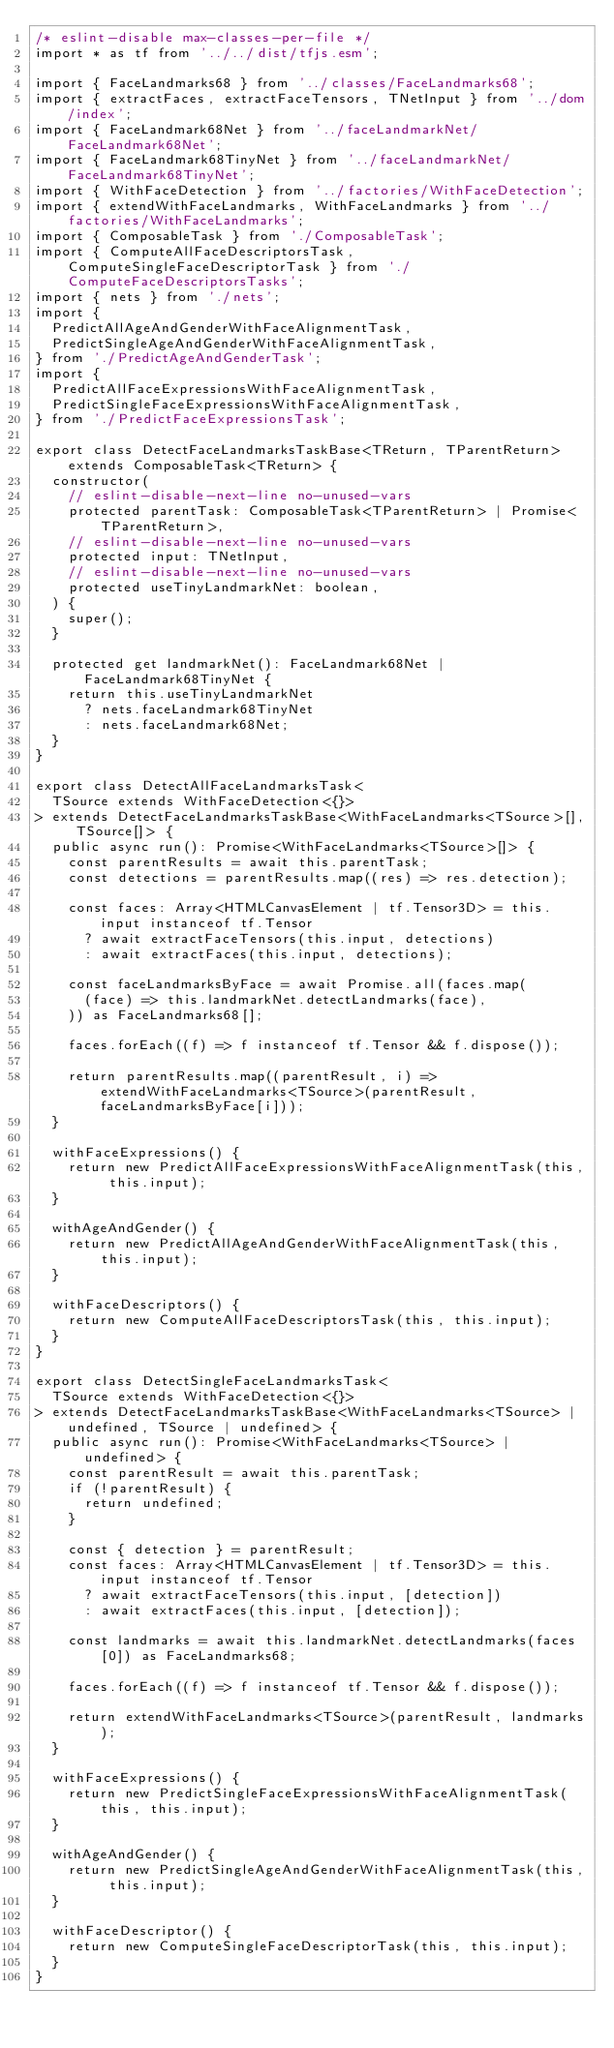<code> <loc_0><loc_0><loc_500><loc_500><_TypeScript_>/* eslint-disable max-classes-per-file */
import * as tf from '../../dist/tfjs.esm';

import { FaceLandmarks68 } from '../classes/FaceLandmarks68';
import { extractFaces, extractFaceTensors, TNetInput } from '../dom/index';
import { FaceLandmark68Net } from '../faceLandmarkNet/FaceLandmark68Net';
import { FaceLandmark68TinyNet } from '../faceLandmarkNet/FaceLandmark68TinyNet';
import { WithFaceDetection } from '../factories/WithFaceDetection';
import { extendWithFaceLandmarks, WithFaceLandmarks } from '../factories/WithFaceLandmarks';
import { ComposableTask } from './ComposableTask';
import { ComputeAllFaceDescriptorsTask, ComputeSingleFaceDescriptorTask } from './ComputeFaceDescriptorsTasks';
import { nets } from './nets';
import {
  PredictAllAgeAndGenderWithFaceAlignmentTask,
  PredictSingleAgeAndGenderWithFaceAlignmentTask,
} from './PredictAgeAndGenderTask';
import {
  PredictAllFaceExpressionsWithFaceAlignmentTask,
  PredictSingleFaceExpressionsWithFaceAlignmentTask,
} from './PredictFaceExpressionsTask';

export class DetectFaceLandmarksTaskBase<TReturn, TParentReturn> extends ComposableTask<TReturn> {
  constructor(
    // eslint-disable-next-line no-unused-vars
    protected parentTask: ComposableTask<TParentReturn> | Promise<TParentReturn>,
    // eslint-disable-next-line no-unused-vars
    protected input: TNetInput,
    // eslint-disable-next-line no-unused-vars
    protected useTinyLandmarkNet: boolean,
  ) {
    super();
  }

  protected get landmarkNet(): FaceLandmark68Net | FaceLandmark68TinyNet {
    return this.useTinyLandmarkNet
      ? nets.faceLandmark68TinyNet
      : nets.faceLandmark68Net;
  }
}

export class DetectAllFaceLandmarksTask<
  TSource extends WithFaceDetection<{}>
> extends DetectFaceLandmarksTaskBase<WithFaceLandmarks<TSource>[], TSource[]> {
  public async run(): Promise<WithFaceLandmarks<TSource>[]> {
    const parentResults = await this.parentTask;
    const detections = parentResults.map((res) => res.detection);

    const faces: Array<HTMLCanvasElement | tf.Tensor3D> = this.input instanceof tf.Tensor
      ? await extractFaceTensors(this.input, detections)
      : await extractFaces(this.input, detections);

    const faceLandmarksByFace = await Promise.all(faces.map(
      (face) => this.landmarkNet.detectLandmarks(face),
    )) as FaceLandmarks68[];

    faces.forEach((f) => f instanceof tf.Tensor && f.dispose());

    return parentResults.map((parentResult, i) => extendWithFaceLandmarks<TSource>(parentResult, faceLandmarksByFace[i]));
  }

  withFaceExpressions() {
    return new PredictAllFaceExpressionsWithFaceAlignmentTask(this, this.input);
  }

  withAgeAndGender() {
    return new PredictAllAgeAndGenderWithFaceAlignmentTask(this, this.input);
  }

  withFaceDescriptors() {
    return new ComputeAllFaceDescriptorsTask(this, this.input);
  }
}

export class DetectSingleFaceLandmarksTask<
  TSource extends WithFaceDetection<{}>
> extends DetectFaceLandmarksTaskBase<WithFaceLandmarks<TSource> | undefined, TSource | undefined> {
  public async run(): Promise<WithFaceLandmarks<TSource> | undefined> {
    const parentResult = await this.parentTask;
    if (!parentResult) {
      return undefined;
    }

    const { detection } = parentResult;
    const faces: Array<HTMLCanvasElement | tf.Tensor3D> = this.input instanceof tf.Tensor
      ? await extractFaceTensors(this.input, [detection])
      : await extractFaces(this.input, [detection]);

    const landmarks = await this.landmarkNet.detectLandmarks(faces[0]) as FaceLandmarks68;

    faces.forEach((f) => f instanceof tf.Tensor && f.dispose());

    return extendWithFaceLandmarks<TSource>(parentResult, landmarks);
  }

  withFaceExpressions() {
    return new PredictSingleFaceExpressionsWithFaceAlignmentTask(this, this.input);
  }

  withAgeAndGender() {
    return new PredictSingleAgeAndGenderWithFaceAlignmentTask(this, this.input);
  }

  withFaceDescriptor() {
    return new ComputeSingleFaceDescriptorTask(this, this.input);
  }
}
</code> 